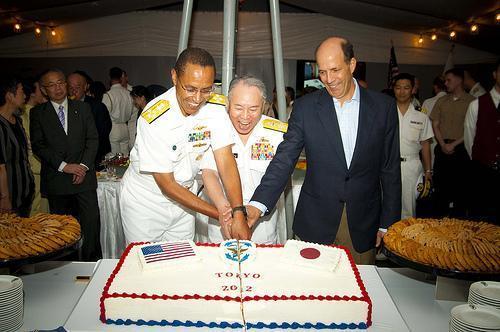How many people are cutting the cake?
Give a very brief answer. 3. 